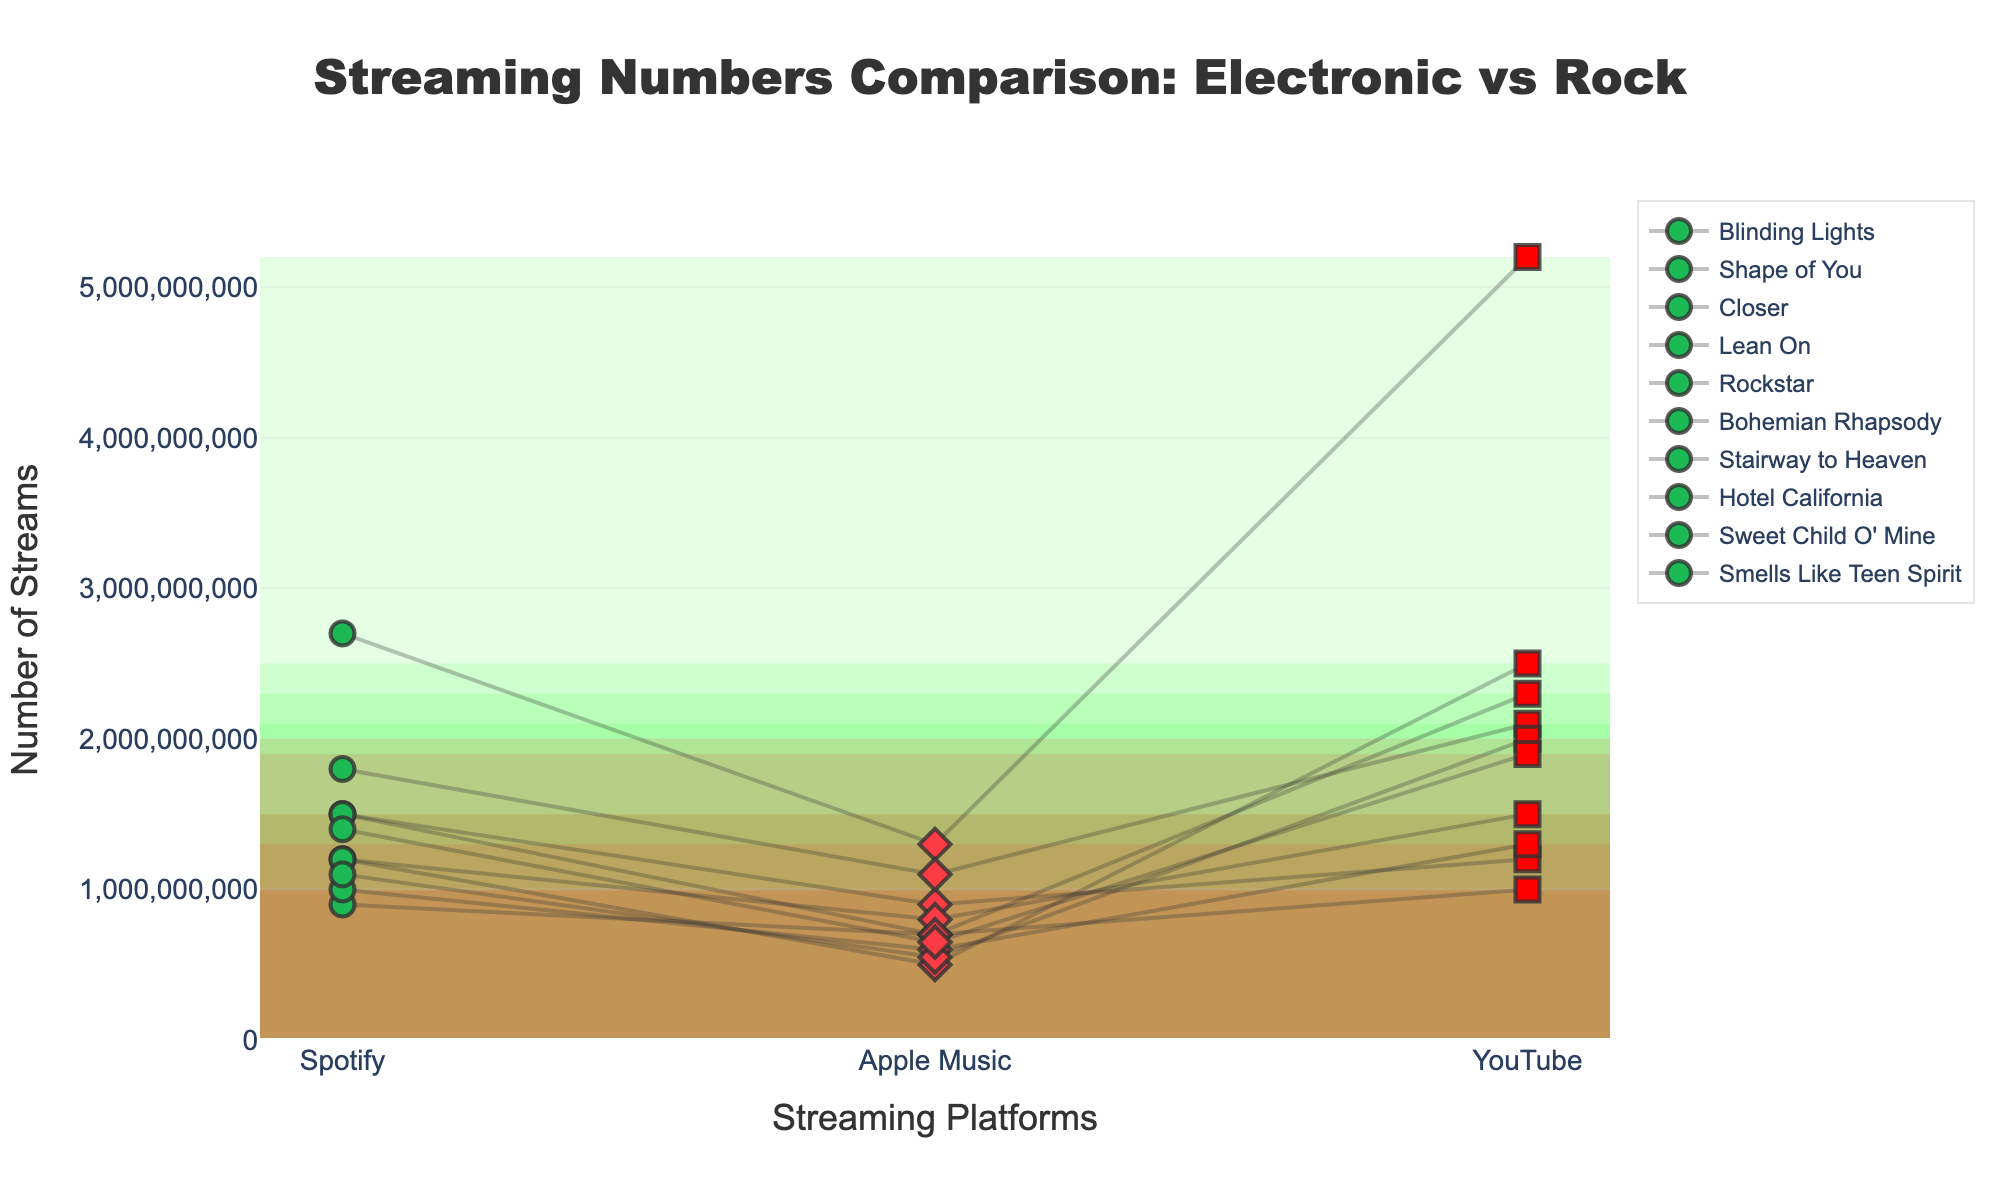What is the title of the figure? The title is displayed at the top center of the figure in large, bold text. It describes what the plot is about.
Answer: Streaming Numbers Comparison: Electronic vs Rock What are the streaming platforms shown on the x-axis? The x-axis contains the different streaming platforms, which are labeled from left to right.
Answer: Spotify, Apple Music, YouTube Which track has the highest number of streams on Spotify? By inspecting the plot and comparing the heights of the markers for Spotify, the highest marker corresponds to the track's name displayed in the legend.
Answer: "Shape of You" (2700000000 streams) Which rock track has the lowest number of streams on Apple Music? By looking at the heights of the markers for Apple Music related to the rock genre and comparing them, the lowest one indicates the track's name.
Answer: "Sweet Child O' Mine" (550000000 streams) What's the average number of streams on YouTube for electronic tracks? To find the average, add up all YouTube streams for electronic tracks and divide by the number of electronic tracks. Sum: 1200000000 (Blinding Lights) + 5200000000 (Shape of You) + 2300000000 (Closer) + 2500000000 (Lean On) + 2100000000 (Rockstar) = 13300000000. Average: 13300000000 / 5 = 2660000000
Answer: 2660000000 Between "Blinding Lights" and "Bohemian Rhapsody", which one has more streams on YouTube? By comparing the height of the markers for YouTube for these two tracks, "Bohemian Rhapsody" would be represented with a lower marker compared to "Blinding Lights".
Answer: "Blinding Lights" Which genre has a wider variation in the number of streams on Apple Music? To determine the variation, compare the difference between the highest and lowest stream counts on Apple Music for each genre. Electronic: highest 1300000000 ("Shape of You") - lowest 500000000 ("Lean On") = 800000000. Rock: highest 800000000 ("Bohemian Rhapsody") - lowest 550000000 ("Sweet Child O' Mine") = 250000000. Electronic has a wider variation.
Answer: Electronic Which track has the most balanced stream counts across all platforms? Balanced stream counts mean the differences among the platforms are small. By visually comparing the spread of dots connected by lines for each track, identify the one where the markers are closest in height.
Answer: "Smells Like Teen Spirit" For the track "Rockstar", how does the number of streams on Apple Music compare to Spotify? Locate "Rockstar" on the plot and compare the height of the markers for Apple Music and Spotify; it is the same or similar.
Answer: Fewer on Apple Music Is there any platform where electronic tracks perform consistently better than rock tracks? For consistency, most or all electronic tracks must have higher markers than all rock tracks on that platform. Examine each platform's markers to determine if this pattern exists.
Answer: Spotify 